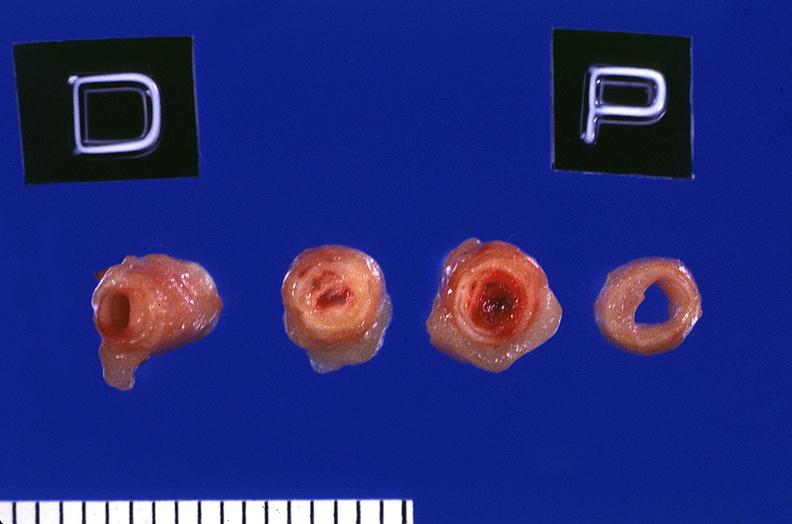s tuberculosis present?
Answer the question using a single word or phrase. No 